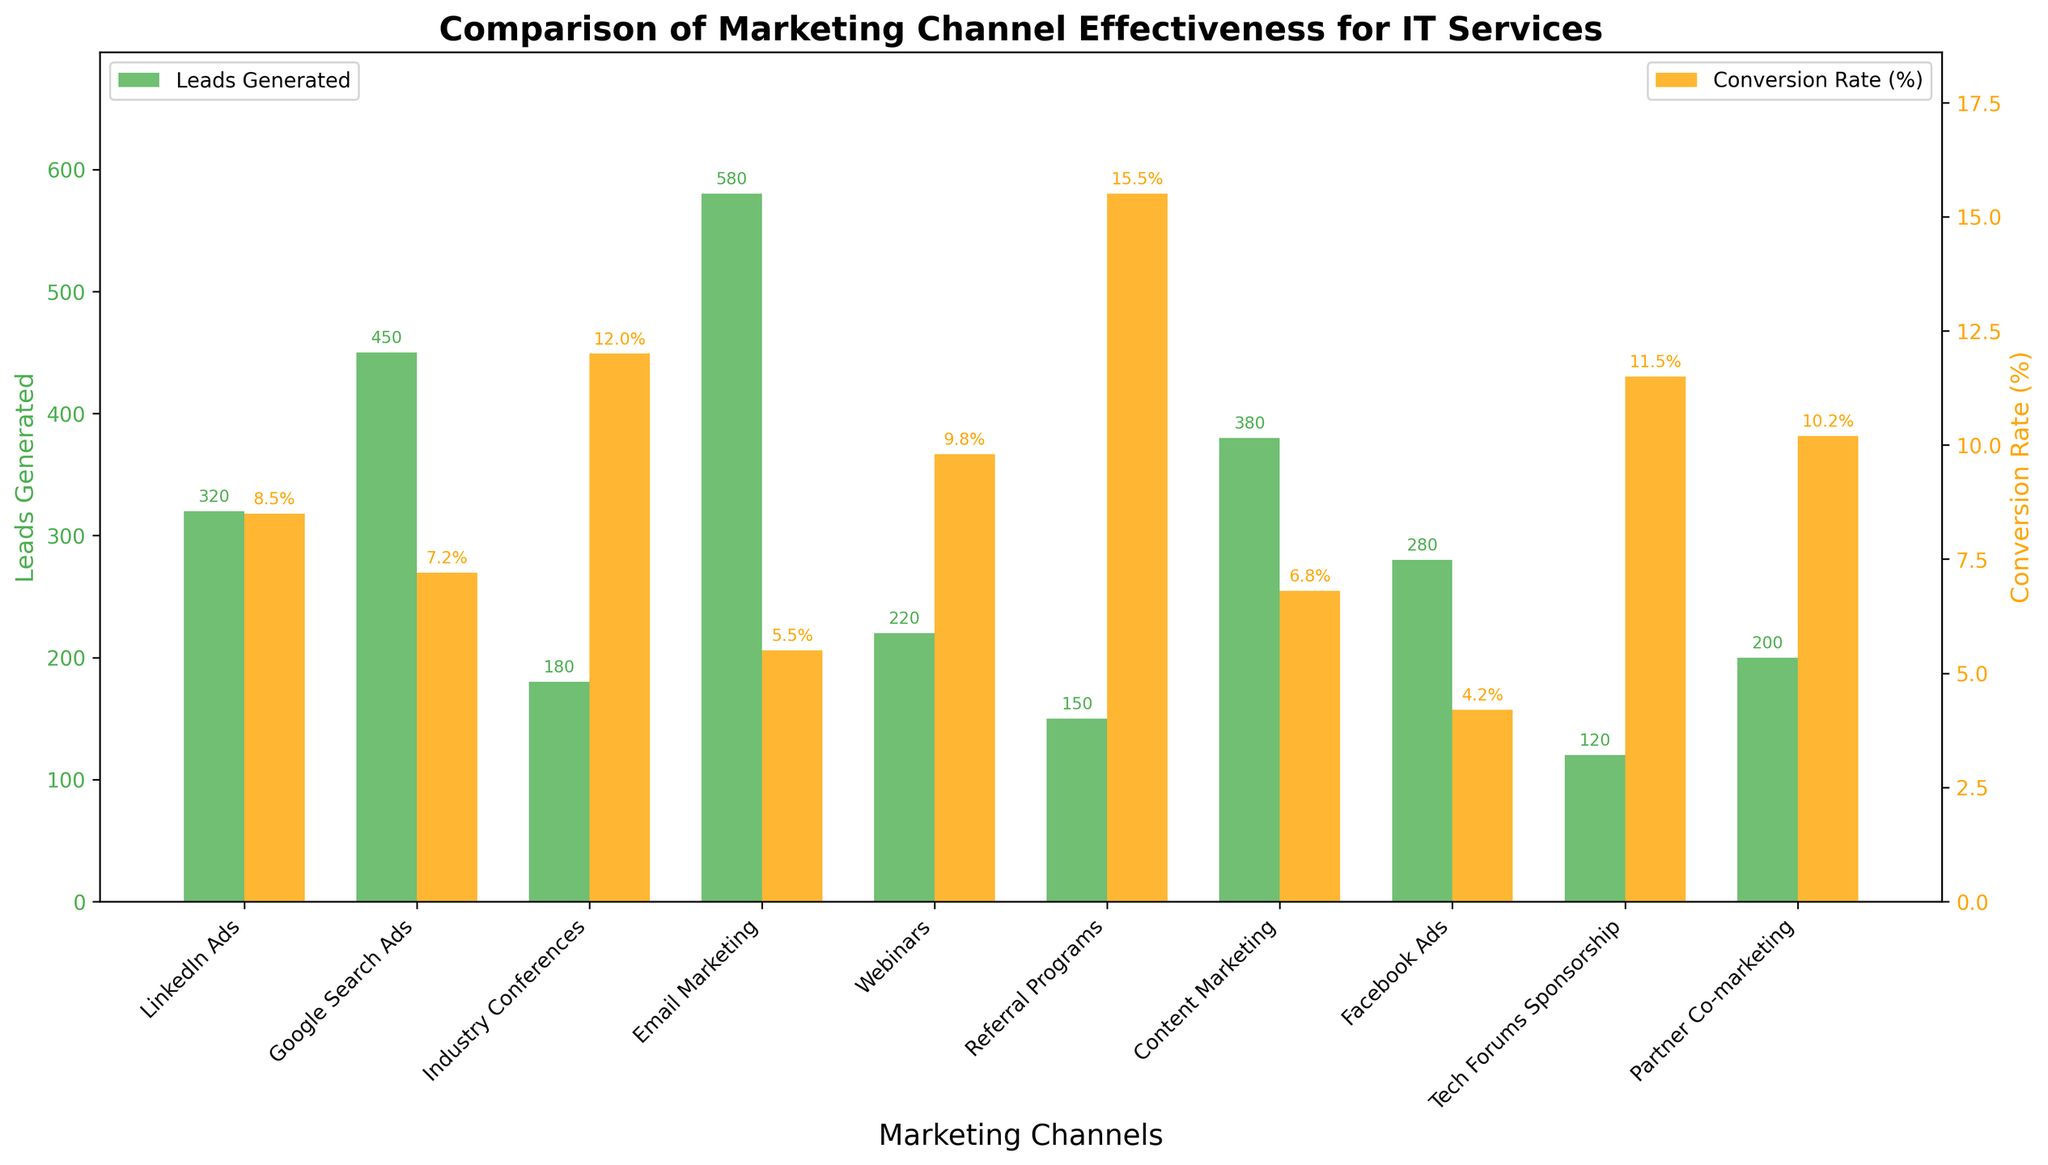What's the total number of leads generated by Google Search Ads and Email Marketing? To find the total number of leads generated by Google Search Ads and Email Marketing, sum the number of leads for both channels. Google Search Ads generated 450 leads, and Email Marketing generated 580 leads. Adding these together gives 450 + 580 = 1030.
Answer: 1030 Which marketing channel has the highest conversion rate? To determine the marketing channel with the highest conversion rate, compare the conversion rates of all channels. Referral Programs have the highest conversion rate at 15.5%.
Answer: Referral Programs Between LinkedIn Ads and Tech Forums Sponsorship, which channel has a higher cost per lead? Compare the cost per lead for LinkedIn Ads and Tech Forums Sponsorship. LinkedIn Ads have a cost per lead of $45, while Tech Forums Sponsorship has a higher cost per lead of $85.
Answer: Tech Forums Sponsorship Which marketing channel has the fewest leads generated and what is the conversion rate for that channel? The channel with the fewest leads generated can be identified by comparing the 'Leads Generated' values. Tech Forums Sponsorship has the fewest leads at 120. The conversion rate for Tech Forums Sponsorship is 11.5%.
Answer: Tech Forums Sponsorship, 11.5% How many more leads does Content Marketing generate compared to Webinars? Subtract the number of leads generated by Webinars from the number of leads generated by Content Marketing. Content Marketing generated 380 leads and Webinars generated 220 leads. So, 380 - 220 = 160 additional leads.
Answer: 160 What is the average conversion rate of LinkedIn Ads, Facebook Ads, and Partner Co-marketing? To find the average conversion rate of these three channels, first add their conversion rates together and then divide by 3. LinkedIn Ads have a conversion rate of 8.5%, Facebook Ads have 4.2%, and Partner Co-marketing has 10.2%. Adding these gives 8.5 + 4.2 + 10.2 = 22.9, and dividing by 3 gives 22.9 / 3 = 7.63%.
Answer: 7.63% Which channel generates the most leads, and how does its conversion rate compare to that of Industry Conferences? Email Marketing generates the most leads with 580. Its conversion rate is 5.5%, whereas Industry Conferences have a conversion rate of 12.0%.
Answer: Email Marketing, lower Among Webinars, Referral Programs, and Content Marketing, which one has the highest ROI (%) and what is it? Compare the ROI (%) for Webinars, Referral Programs, and Content Marketing. Referral Programs have the highest ROI at 300%.
Answer: Referral Programs, 300% Rank the top three channels by conversion rate. To rank the top three channels by conversion rate, sort the channels based on their conversion rates. The top three are: Referral Programs (15.5%), Industry Conferences (12.0%), and Tech Forums Sponsorship (11.5%).
Answer: Referral Programs, Industry Conferences, Tech Forums Sponsorship Is the conversion rate of Facebook Ads higher or lower than that of Google Search Ads, and by how much? Compare the conversion rates of Facebook Ads and Google Search Ads. Facebook Ads have a conversion rate of 4.2%, while Google Search Ads have 7.2%. The difference is 7.2 - 4.2 = 3.0%.
Answer: Lower by 3.0% 